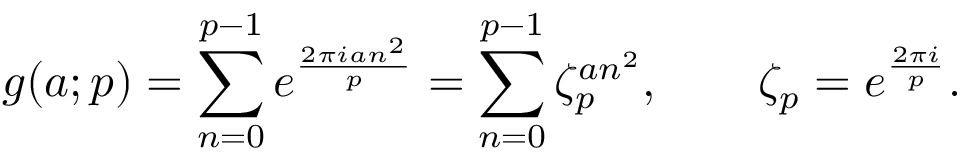Convert formula to latex. <formula><loc_0><loc_0><loc_500><loc_500>g ( a ; p ) = \sum _ { n = 0 } ^ { p - 1 } e ^ { \frac { 2 \pi i a n ^ { 2 } } { p } } = \sum _ { n = 0 } ^ { p - 1 } \zeta _ { p } ^ { a n ^ { 2 } } , \quad \zeta _ { p } = e ^ { \frac { 2 \pi i } { p } } .</formula> 